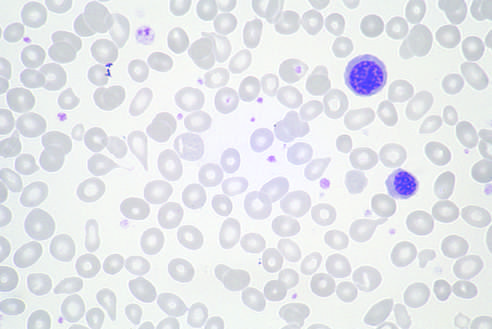how many nucleated erythroid precursors are evident?
Answer the question using a single word or phrase. Two 